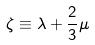<formula> <loc_0><loc_0><loc_500><loc_500>\zeta \equiv \lambda + \frac { 2 } { 3 } \mu</formula> 